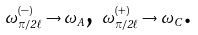Convert formula to latex. <formula><loc_0><loc_0><loc_500><loc_500>\omega _ { \pi / 2 \ell } ^ { ( - ) } \rightarrow \omega _ { A } \text {, } \omega _ { \pi / 2 \ell } ^ { ( + ) } \rightarrow \omega _ { C } \text {.}</formula> 